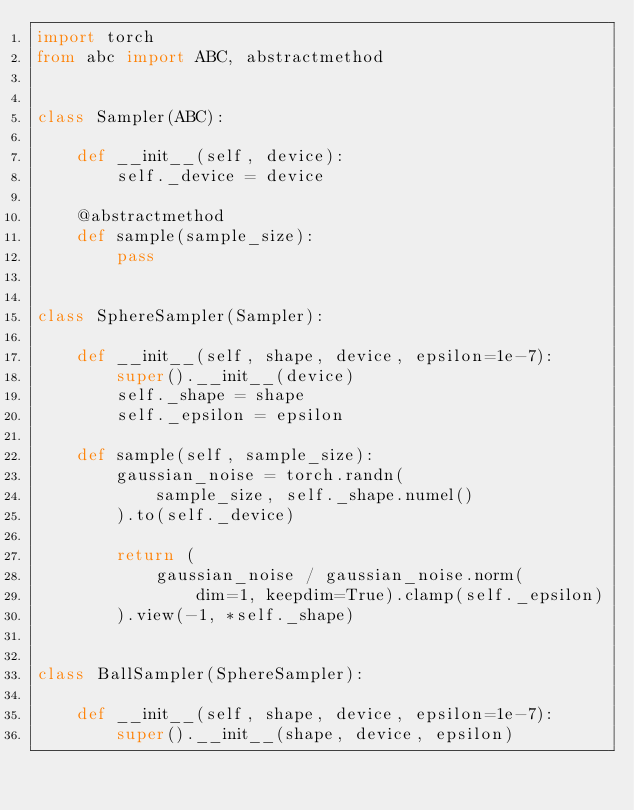<code> <loc_0><loc_0><loc_500><loc_500><_Python_>import torch
from abc import ABC, abstractmethod


class Sampler(ABC):

    def __init__(self, device):
        self._device = device

    @abstractmethod
    def sample(sample_size):
        pass


class SphereSampler(Sampler):

    def __init__(self, shape, device, epsilon=1e-7):
        super().__init__(device)
        self._shape = shape
        self._epsilon = epsilon

    def sample(self, sample_size):
        gaussian_noise = torch.randn(
            sample_size, self._shape.numel()
        ).to(self._device)

        return (
            gaussian_noise / gaussian_noise.norm(
                dim=1, keepdim=True).clamp(self._epsilon)
        ).view(-1, *self._shape)


class BallSampler(SphereSampler):

    def __init__(self, shape, device, epsilon=1e-7):
        super().__init__(shape, device, epsilon)</code> 